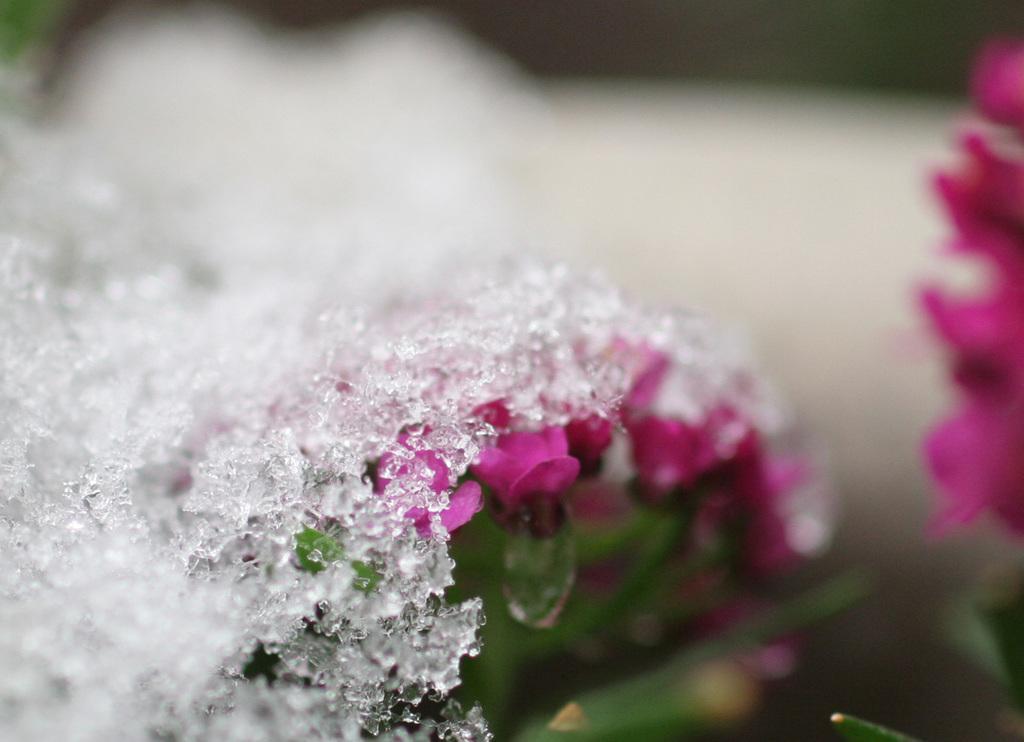In one or two sentences, can you explain what this image depicts? In this image in the front there is an object which is white in colour and in the center there are flowers and the background is blurry. 